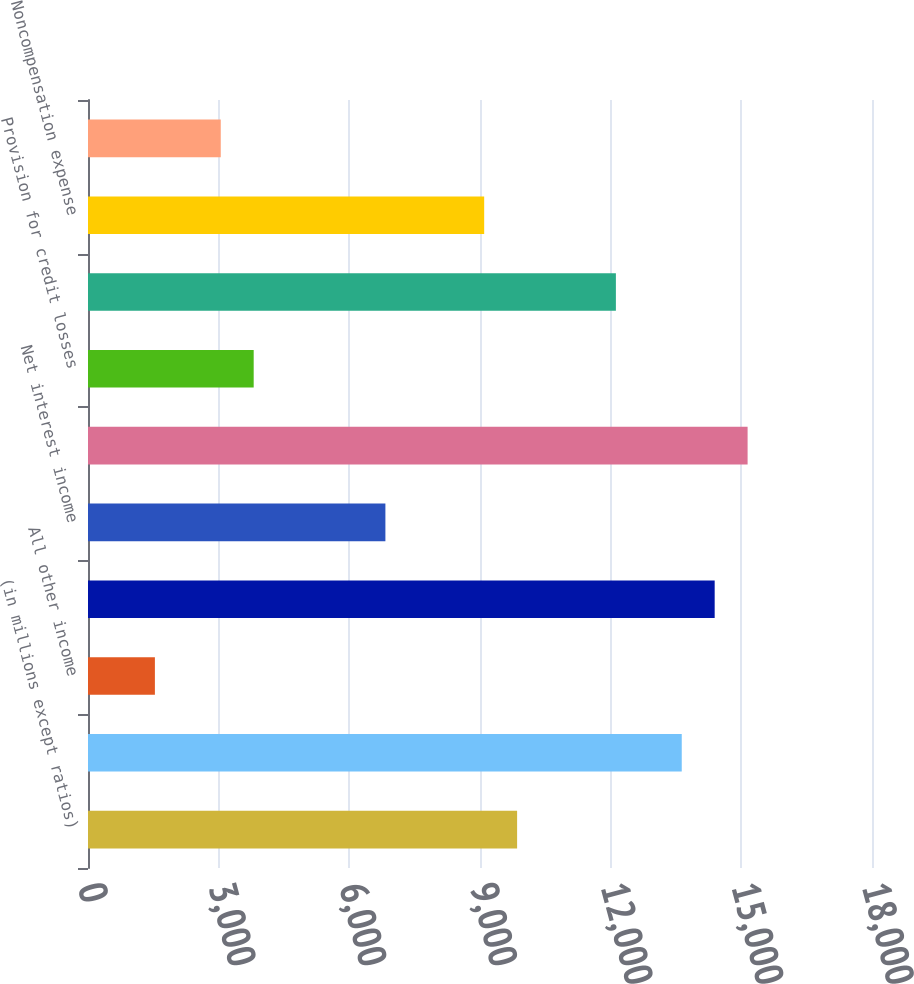Convert chart to OTSL. <chart><loc_0><loc_0><loc_500><loc_500><bar_chart><fcel>(in millions except ratios)<fcel>Asset management<fcel>All other income<fcel>Noninterest revenue<fcel>Net interest income<fcel>Total net revenue<fcel>Provision for credit losses<fcel>Compensation expense<fcel>Noncompensation expense<fcel>Amortization of intangibles<nl><fcel>9852<fcel>13632<fcel>1536<fcel>14388<fcel>6828<fcel>15144<fcel>3804<fcel>12120<fcel>9096<fcel>3048<nl></chart> 